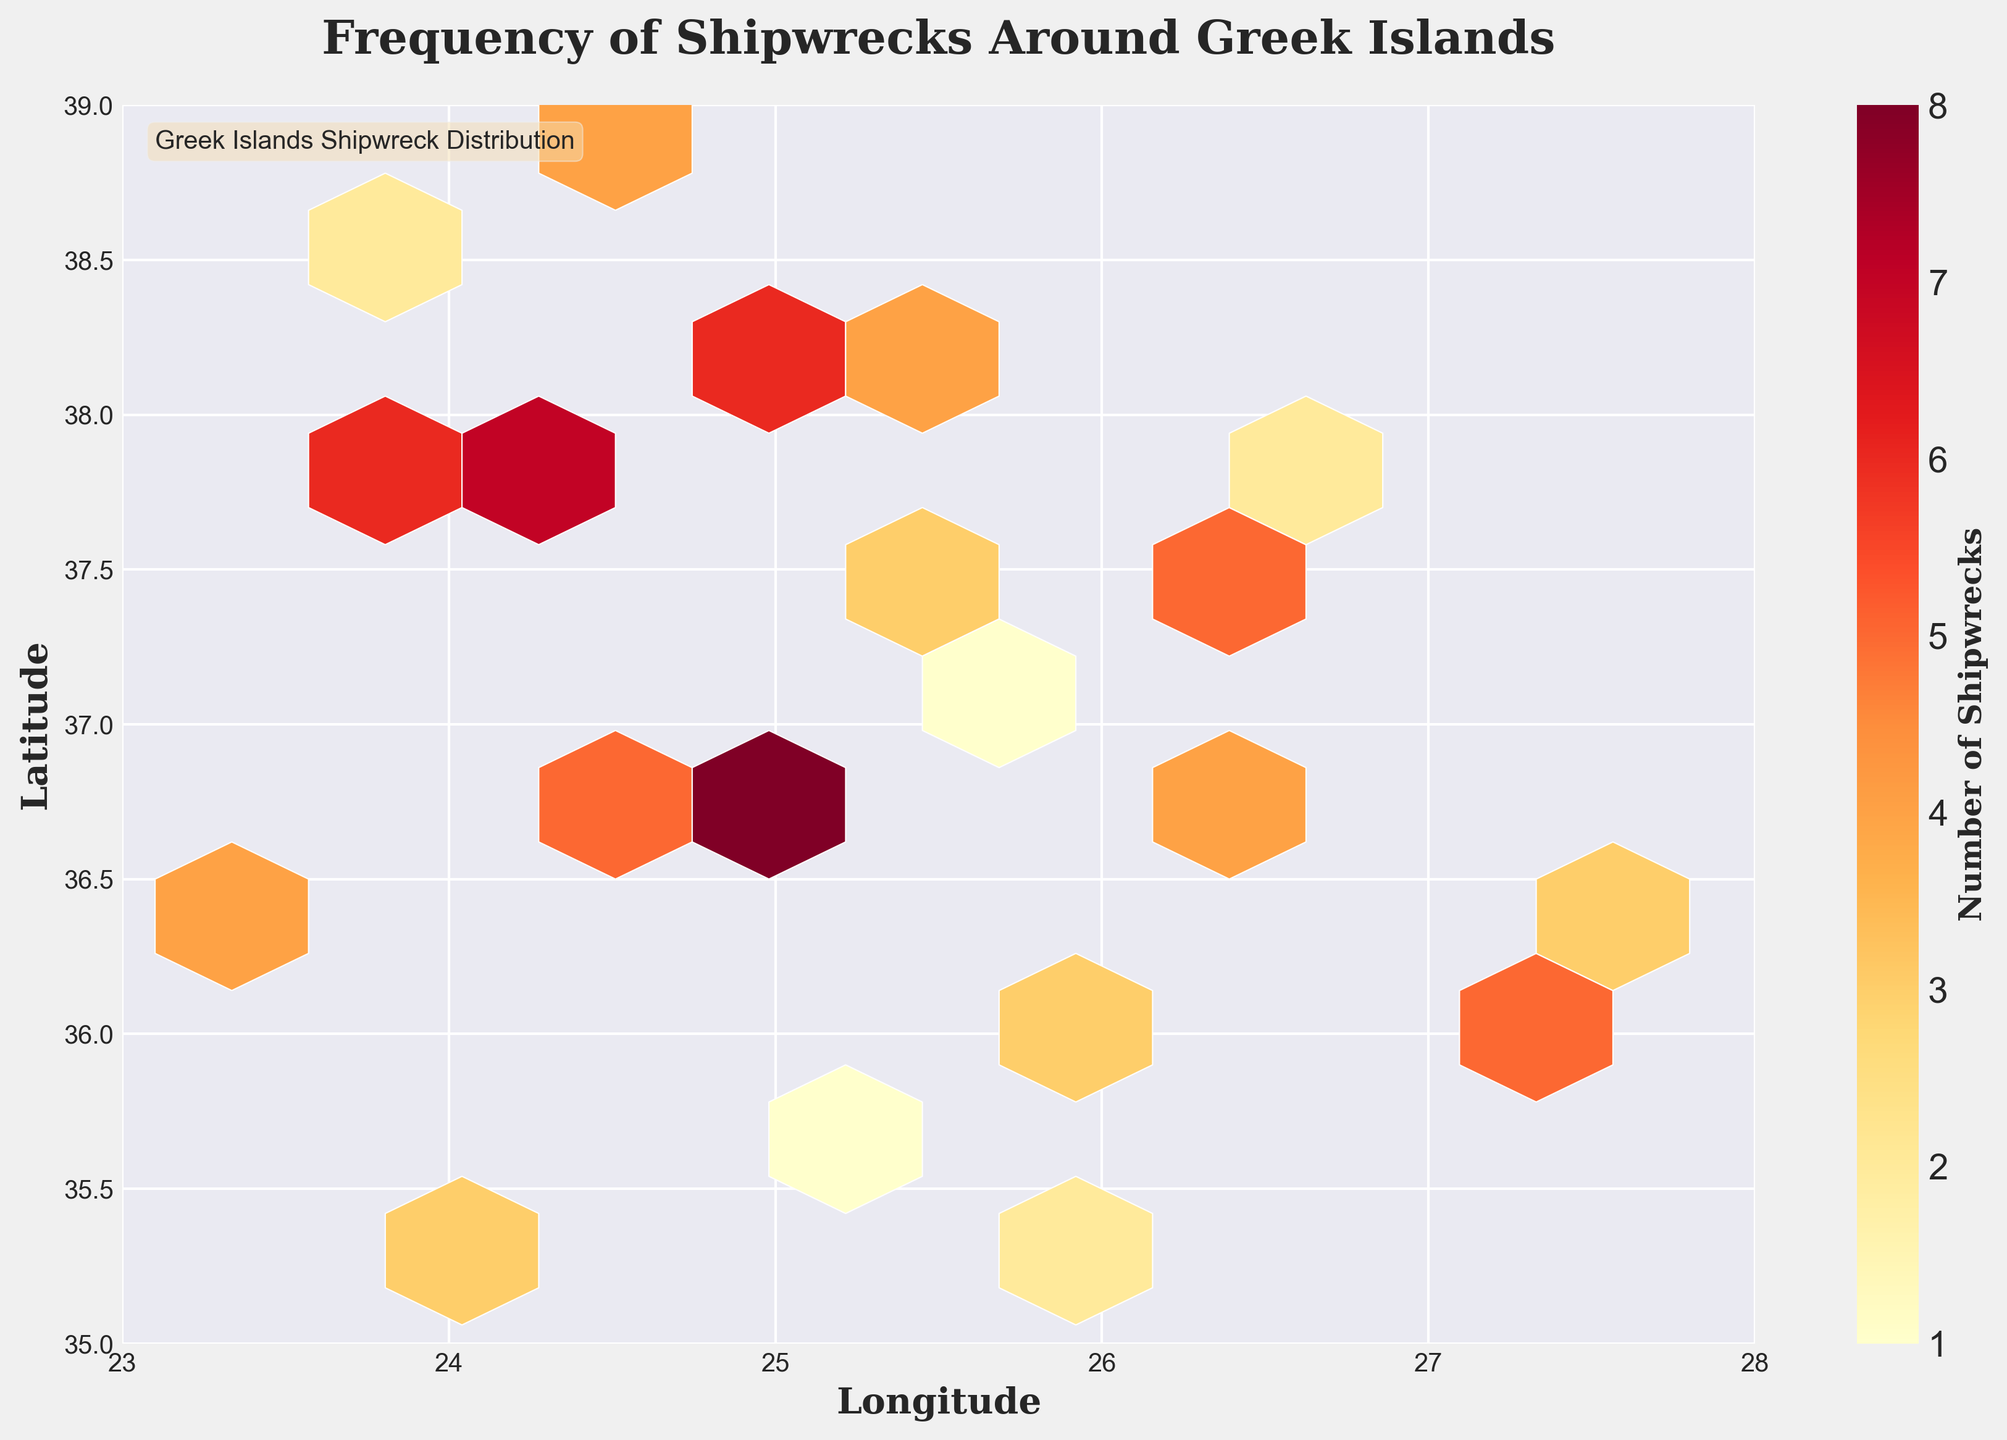what is the title of the plot? The title of the plot is located at the top and reads 'Frequency of Shipwrecks Around Greek Islands'.
Answer: Frequency of Shipwrecks Around Greek Islands what do the colors in the hexagons represent? The colors in the hexagons represent the number of shipwrecks found in each area, as indicated by the color bar on the right side of the plot. Darker colors signify more shipwrecks.
Answer: The number of shipwrecks Which area around the Greek islands has the highest concentration of shipwrecks? The highest concentration of shipwrecks can be seen in the darkest hexagon on the plot, around the coordinates with higher Longitude near the center of the range and lower Latitude towards the lower-middle of the range.
Answer: Around the central-longitude and lower-middle-latitude area What's the range of latitudes shown on the plot? The Y-axis represents the latitude, with the axis labeled from 35 to 39 degrees.
Answer: 35 to 39 what is the label of the color bar? The color bar, which shows the density of shipwrecks, is labeled as 'Number of Shipwrecks'.
Answer: Number of Shipwrecks In which range of longitudes do we see the most shipwrecks? By identifying the darker hexagons in the plot, we observe that most shipwrecks are concentrated around longitudes approximately between 24 and 26 degrees.
Answer: 24 to 26 degrees What is the range of depths shown for the shipwrecked areas? The data includes depth values ranging from 30 meters to 150 meters, which corresponds to the variation seen in the region-specific hexagons on the plot.
Answer: 30 to 150 meters Are there more shipwrecks found in the eastern or western parts of the plotted area? Looking at the concentration of darker hexagons, we see more shipwrecks in the western part of the plotted area (longitudes closer to 23 and 24).
Answer: Western part What's the grid size utilized in the hexbin plot? The grid size governs how hexagons are distributed across the plot. As per the details, a grid size of 10 is used. (This is inferred from the code, though usually visible through contour and density).
Answer: Grid size 10 At which depth range are the most shipwrecks discovered? To determine the depth range with the most shipwrecks, we analyze the colors and note that most shipwrecks are concentrated across varying depth zones, but around mid-depths (approximately 40-80m) have more consistent concentration.
Answer: Around 40-80 meters 